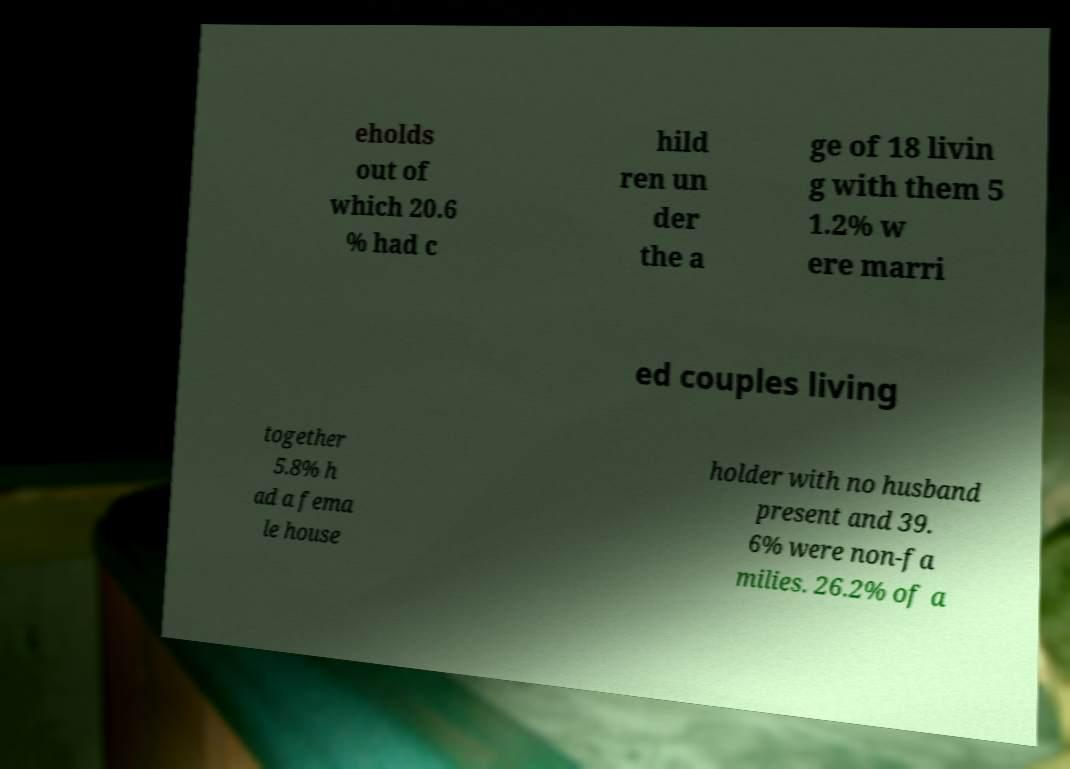Could you assist in decoding the text presented in this image and type it out clearly? eholds out of which 20.6 % had c hild ren un der the a ge of 18 livin g with them 5 1.2% w ere marri ed couples living together 5.8% h ad a fema le house holder with no husband present and 39. 6% were non-fa milies. 26.2% of a 